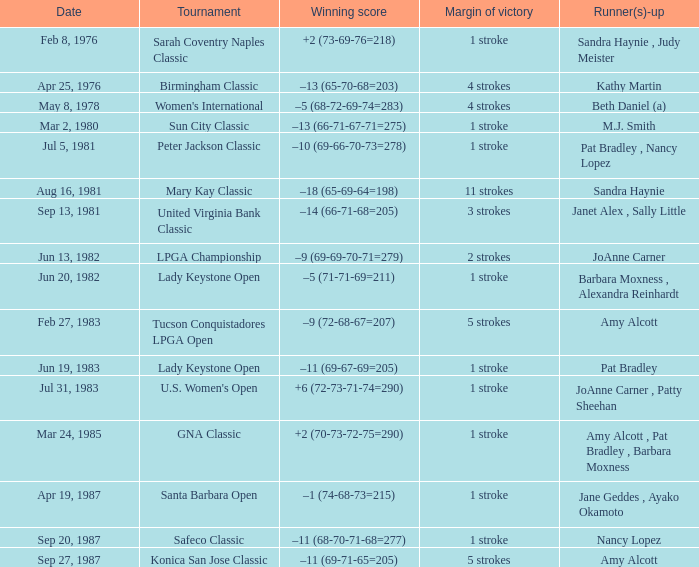How many points separate the winner from the runner-up in the konica san jose classic tournament? 5 strokes. 